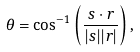<formula> <loc_0><loc_0><loc_500><loc_500>\theta = \cos ^ { - 1 } \left ( \frac { { s } \cdot { r } } { | { s } | | { r } | } \right ) ,</formula> 